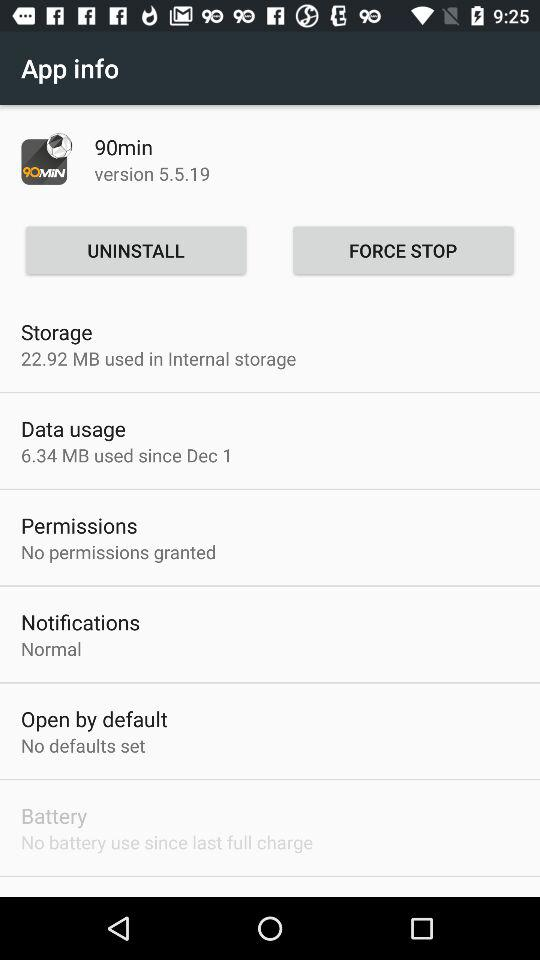What is the application name? The application name is "90min". 